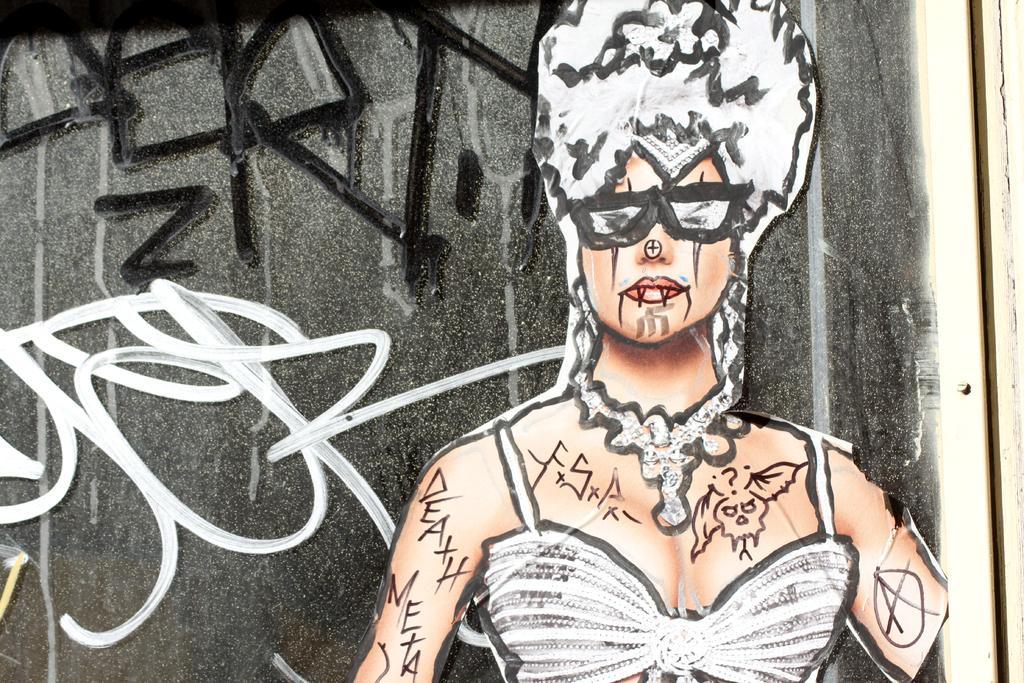Can you describe this image briefly? In this picture we can see a wall, there is a painting of a woman on the wall. 